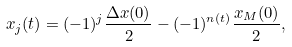Convert formula to latex. <formula><loc_0><loc_0><loc_500><loc_500>x _ { j } ( t ) = ( - 1 ) ^ { j } \frac { \Delta x ( 0 ) } { 2 } - ( - 1 ) ^ { n ( t ) } \frac { x _ { M } ( 0 ) } { 2 } ,</formula> 